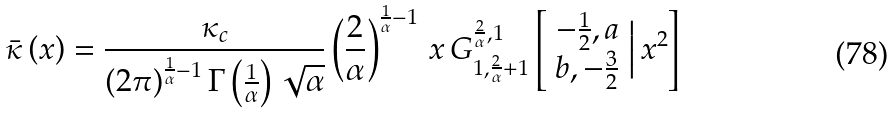Convert formula to latex. <formula><loc_0><loc_0><loc_500><loc_500>\bar { \kappa } \left ( x \right ) = \frac { \kappa _ { c } } { \left ( 2 \pi \right ) ^ { \frac { 1 } { \alpha } - 1 } \Gamma \left ( \frac { 1 } { \alpha } \right ) \sqrt { \alpha } } \left ( \frac { 2 } { \alpha } \right ) ^ { \frac { 1 } { \alpha } - 1 } \, x \, G _ { 1 , \frac { 2 } { \alpha } + 1 } ^ { \frac { 2 } { \alpha } , 1 } \left [ \begin{array} { c } - \frac { 1 } { 2 } , a \\ b , - \frac { 3 } { 2 } \end{array} \Big | \, x ^ { 2 } \right ]</formula> 